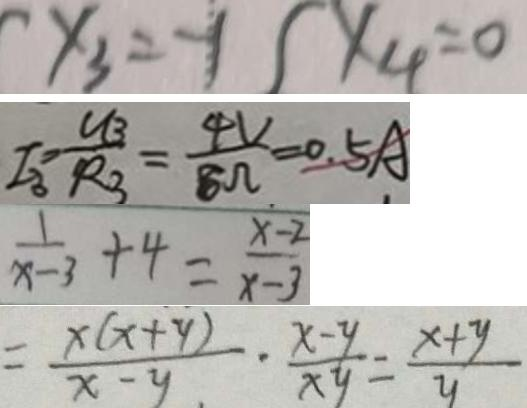Convert formula to latex. <formula><loc_0><loc_0><loc_500><loc_500>x _ { 3 } = - 1 ( x _ { 4 } = 0 
 I _ { 3 } = \frac { U _ { 3 } } { R _ { 3 } } = \frac { 4 V } { 8 \Omega } = 0 . 5 A 
 \frac { 1 } { x - 3 } + 4 = \frac { x - 2 } { x - 3 } 
 = \frac { x ( x + y ) } { x - y } \cdot \frac { x - y } { x y } = \frac { x + y } { y }</formula> 